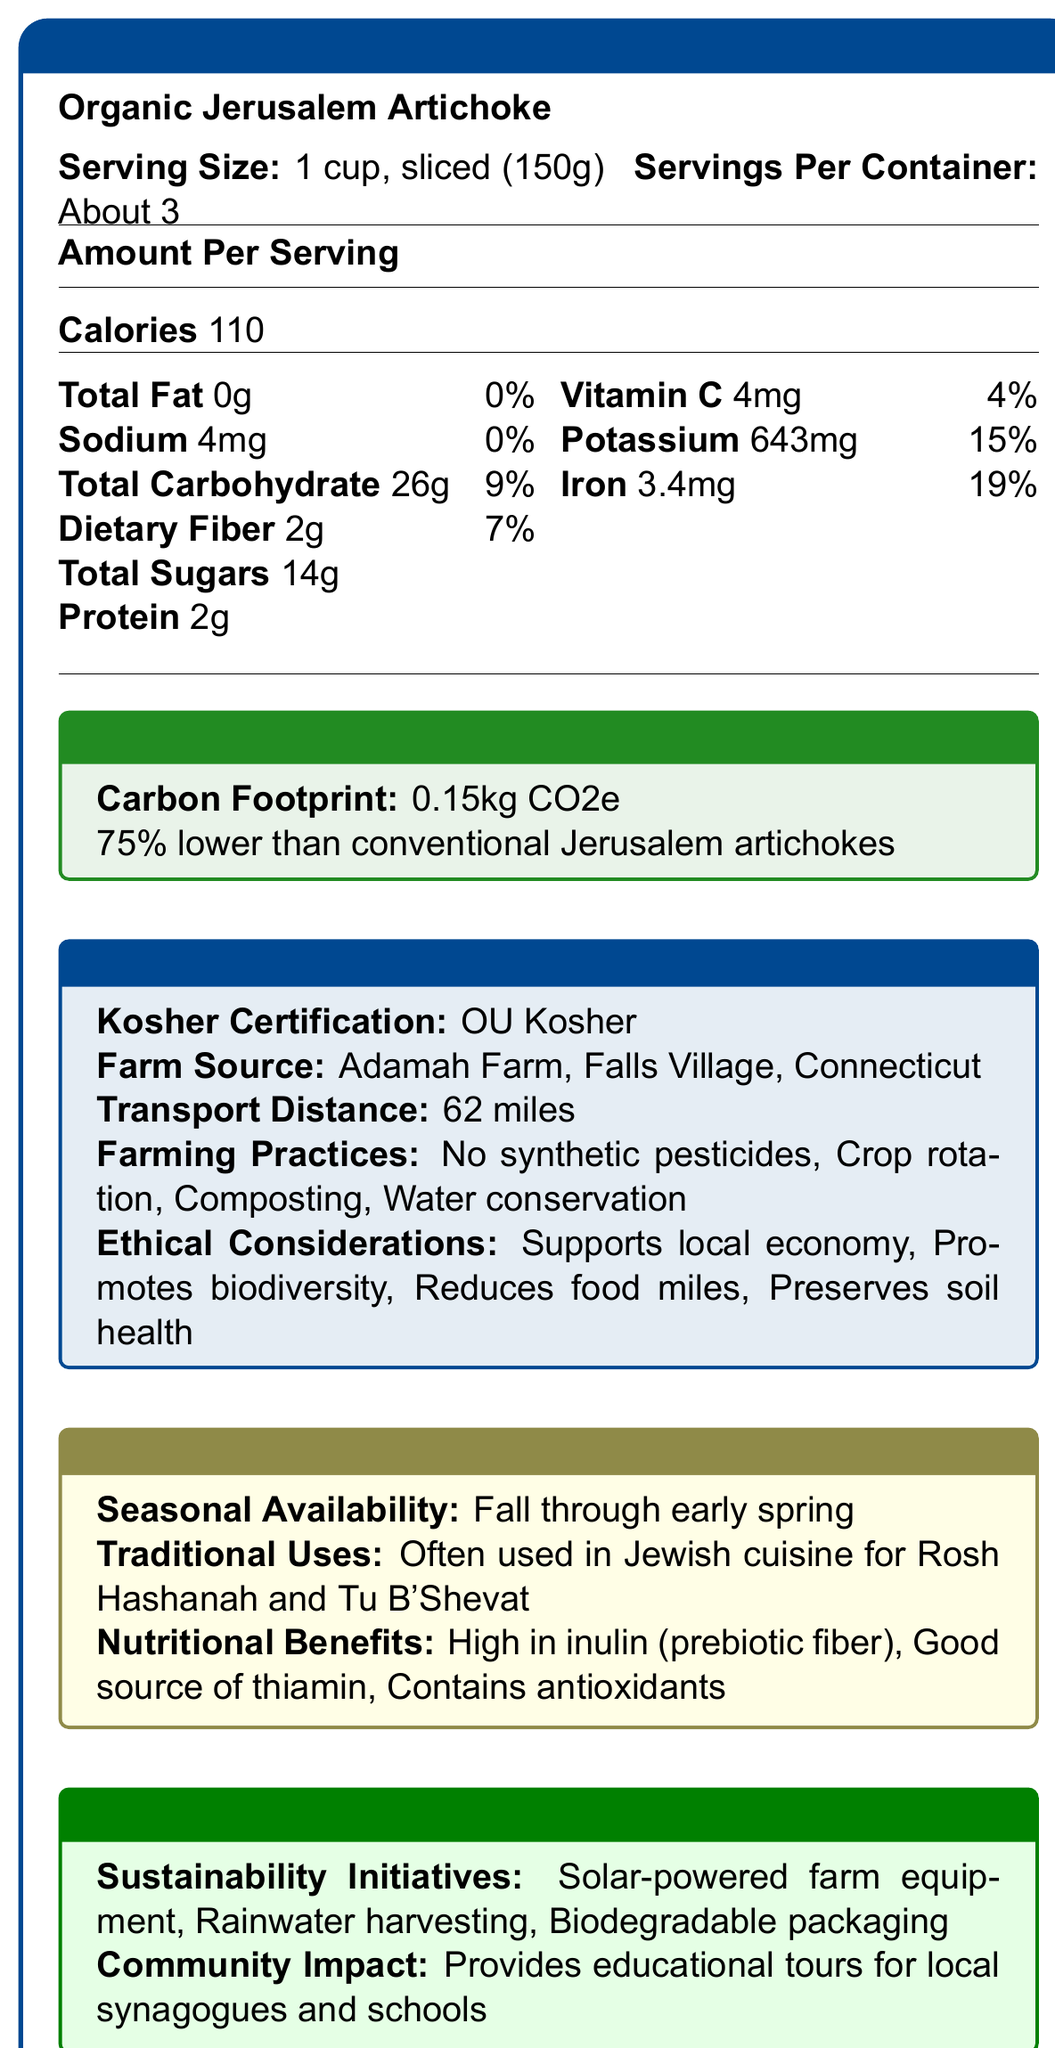What is the serving size of the Organic Jerusalem Artichoke? The document lists the serving size clearly as "1 cup, sliced (150g)".
Answer: 1 cup, sliced (150g) How many servings per container are there? The document specifies that there are "About 3" servings per container.
Answer: About 3 What is the total carbohydrate content per serving? The document shows that each serving contains 26 grams of total carbohydrates.
Answer: 26g What is the carbon footprint of the Organic Jerusalem Artichoke? The document states that the carbon footprint is "0.15kg CO2e".
Answer: 0.15kg CO2e Which farm sources the Organic Jerusalem Artichoke? The farm source is clearly listed as "Adamah Farm, Falls Village, Connecticut".
Answer: Adamah Farm, Falls Village, Connecticut What are some traditional uses of the Organic Jerusalem Artichoke? The document mentions its traditional uses as "Often used in Jewish cuisine for Rosh Hashanah and Tu B'Shevat".
Answer: Often used in Jewish cuisine for Rosh Hashanah and Tu B'Shevat What is the potassium content per serving? The potassium content per serving is listed as 643mg in the document.
Answer: 643mg What are the key nutritional benefits of the Organic Jerusalem Artichoke? The document states that the nutritional benefits include being high in inulin, a good source of thiamin, and containing antioxidants.
Answer: High in inulin, good source of thiamin, contains antioxidants What are some ethical considerations mentioned for the Organic Jerusalem Artichoke? The document lists these ethical considerations among others.
Answer: Supports local economy, promotes biodiversity, reduces food miles, preserves soil health What kosher certification does the Organic Jerusalem Artichoke have? The document indicates that the product is certified by OU Kosher.
Answer: OU Kosher How far is the transport distance for the Organic Jerusalem Artichoke? The document states that the transport distance is 62 miles.
Answer: 62 miles Which of the following farming practices is NOT mentioned for the Organic Jerusalem Artichoke? A. No synthetic pesticides B. Crop rotation C. Organic fertilizers D. Water conservation The document mentions "No synthetic pesticides," "Crop rotation," and "Water conservation" but does not mention "Organic fertilizers".
Answer: C. Organic fertilizers Which seasonal period is the Organic Jerusalem Artichoke available? A. Summer B. Fall through early spring C. Winter D. Year-round The document indicates that the product is available "Fall through early spring".
Answer: B. Fall through early spring Does the Organic Jerusalem Artichoke provide educational tours for local synagogues and schools? The document states that the farm provides educational tours for local synagogues and schools.
Answer: Yes Is the carbon footprint of the Organic Jerusalem Artichoke higher than that of conventional Jerusalem artichokes? The document says the carbon footprint is "75% lower than conventional Jerusalem artichokes".
Answer: No Can the sodium content in the Organic Jerusalem Artichoke be considered high? The document lists the sodium content as 4mg per serving, which is 0% of the daily value, indicating it is low.
Answer: No Summarize the key points about the Organic Jerusalem Artichoke from the document. The document describes various aspects related to nutrition, environmental impact, kosher certification, farming practices, ethical considerations, cultural significance, sustainability initiatives, and community impact for the Organic Jerusalem Artichoke.
Answer: The Organic Jerusalem Artichoke is a kosher-certified, environmentally friendly product sourced from Adamah Farm in Falls Village, Connecticut. It has a low carbon footprint, is high in inulin, a good source of thiamin, and contains antioxidants. Farming practices include no synthetic pesticides, crop rotation, composting, and water conservation. The product supports the local economy, promotes biodiversity, reduces food miles, and preserves soil health. It is available from fall through early spring and is traditionally used in Jewish cuisine during Rosh Hashanah and Tu B'Shevat. The farm also engages in sustainability initiatives and provides educational tours for local communities. What percentage of daily value for iron does one serving of Organic Jerusalem Artichoke provide? The document lists the iron content as providing 19% of the daily value.
Answer: 19% What type of packaging does the Organic Jerusalem Artichoke use? The document does not provide specific details about the type of packaging used, except that it is "biodegradable packaging".
Answer: Cannot be determined 